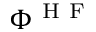Convert formula to latex. <formula><loc_0><loc_0><loc_500><loc_500>\Phi ^ { H F }</formula> 